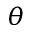Convert formula to latex. <formula><loc_0><loc_0><loc_500><loc_500>\theta</formula> 